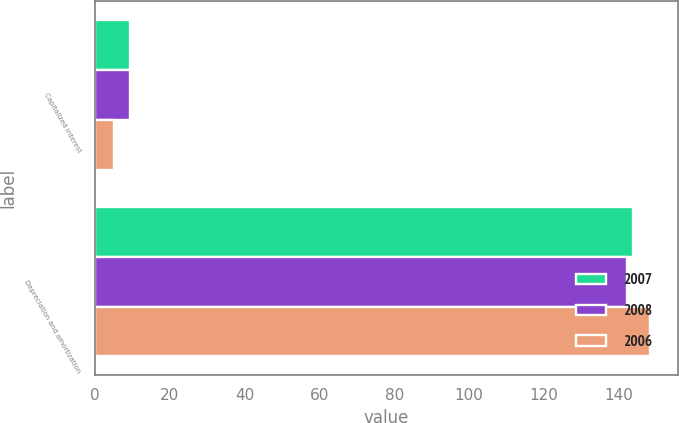Convert chart. <chart><loc_0><loc_0><loc_500><loc_500><stacked_bar_chart><ecel><fcel>Capitalized interest<fcel>Depreciation and amortization<nl><fcel>2007<fcel>9.3<fcel>143.9<nl><fcel>2008<fcel>9.5<fcel>142.1<nl><fcel>2006<fcel>5.2<fcel>148.4<nl></chart> 